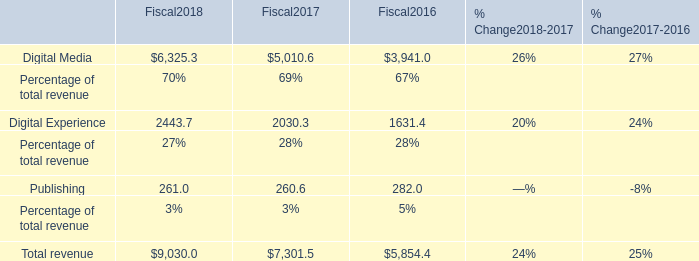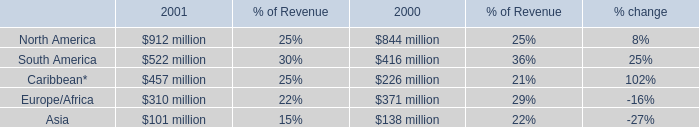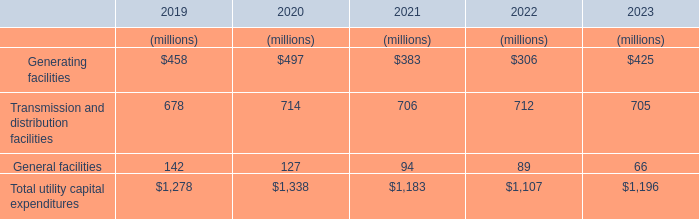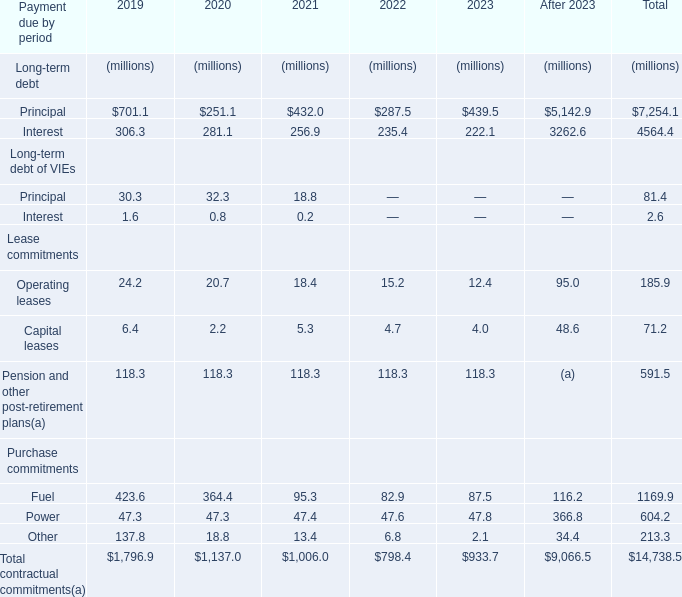What is the average value of Generating facilities in 2019, 2020, and 2021? (in million) 
Computations: (((458 + 497) + 383) / 3)
Answer: 446.0. 